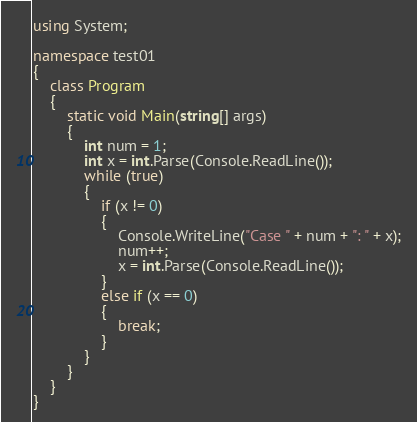Convert code to text. <code><loc_0><loc_0><loc_500><loc_500><_C#_>using System;

namespace test01
{
    class Program
    {
        static void Main(string[] args)
        {
            int num = 1;
            int x = int.Parse(Console.ReadLine());
            while (true)
            {
                if (x != 0)
                {
                    Console.WriteLine("Case " + num + ": " + x);
                    num++;
                    x = int.Parse(Console.ReadLine());
                }
                else if (x == 0)
                {
                    break;
                }
            }
        }
    }
}</code> 